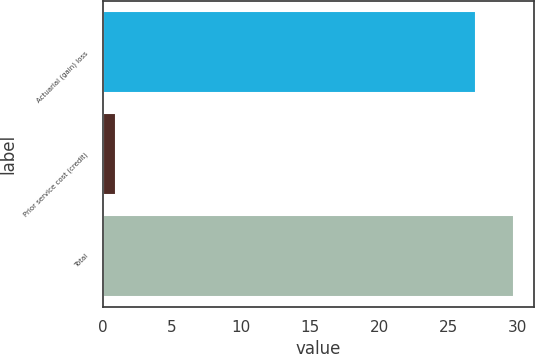Convert chart. <chart><loc_0><loc_0><loc_500><loc_500><bar_chart><fcel>Actuarial (gain) loss<fcel>Prior service cost (credit)<fcel>Total<nl><fcel>27<fcel>1<fcel>29.7<nl></chart> 